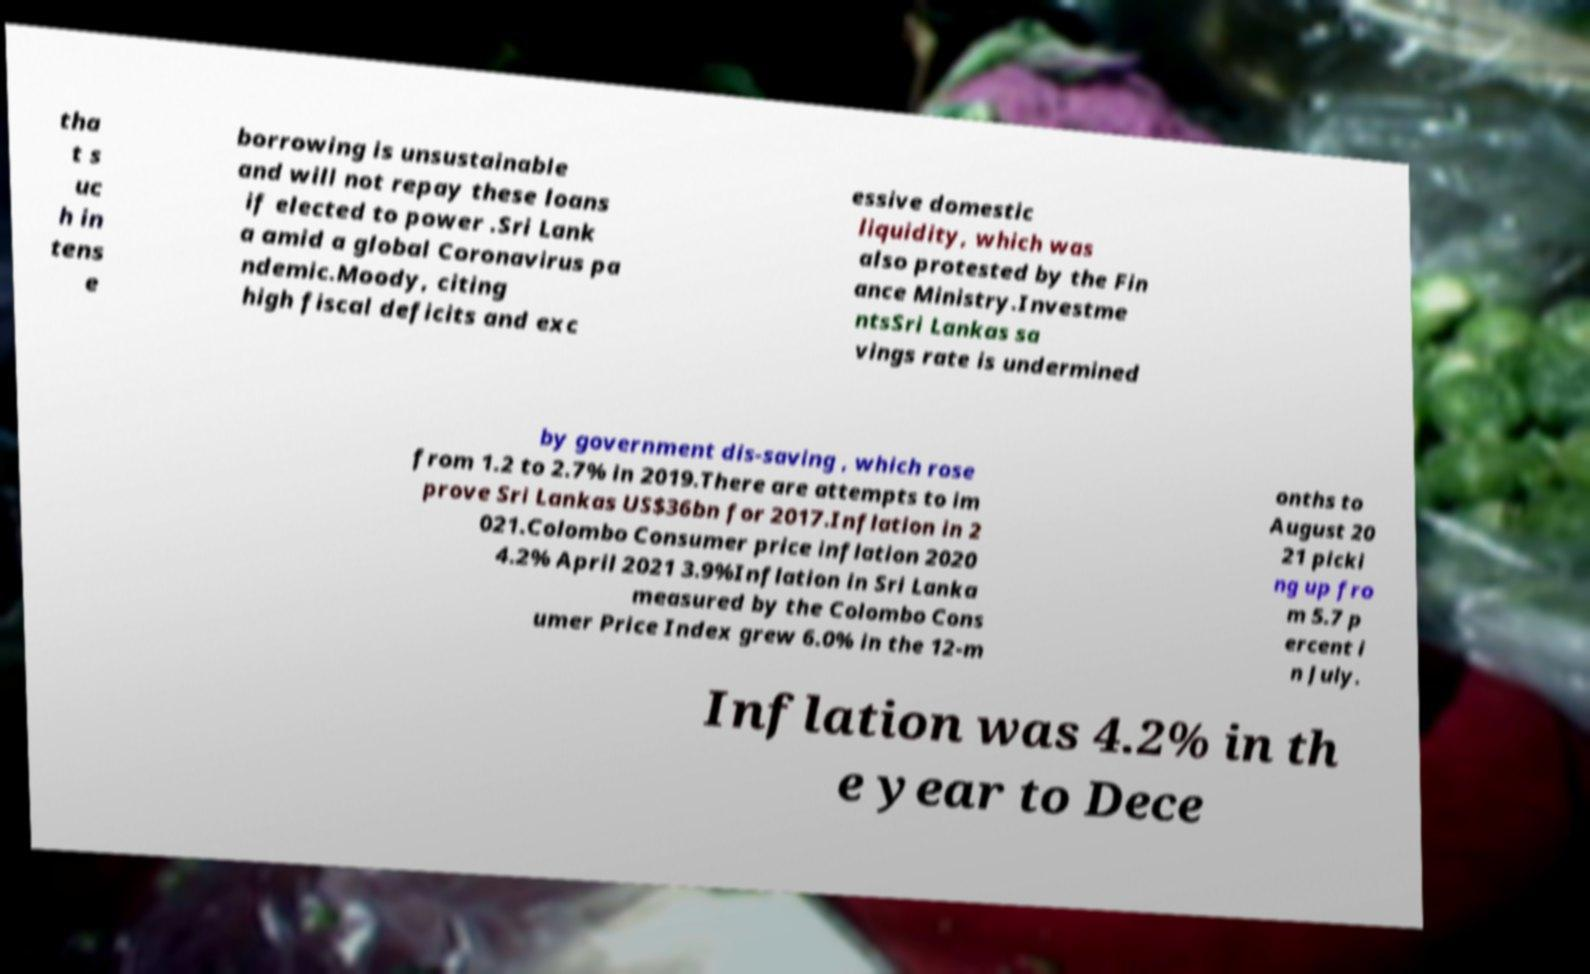There's text embedded in this image that I need extracted. Can you transcribe it verbatim? tha t s uc h in tens e borrowing is unsustainable and will not repay these loans if elected to power .Sri Lank a amid a global Coronavirus pa ndemic.Moody, citing high fiscal deficits and exc essive domestic liquidity, which was also protested by the Fin ance Ministry.Investme ntsSri Lankas sa vings rate is undermined by government dis-saving , which rose from 1.2 to 2.7% in 2019.There are attempts to im prove Sri Lankas US$36bn for 2017.Inflation in 2 021.Colombo Consumer price inflation 2020 4.2% April 2021 3.9%Inflation in Sri Lanka measured by the Colombo Cons umer Price Index grew 6.0% in the 12-m onths to August 20 21 picki ng up fro m 5.7 p ercent i n July. Inflation was 4.2% in th e year to Dece 